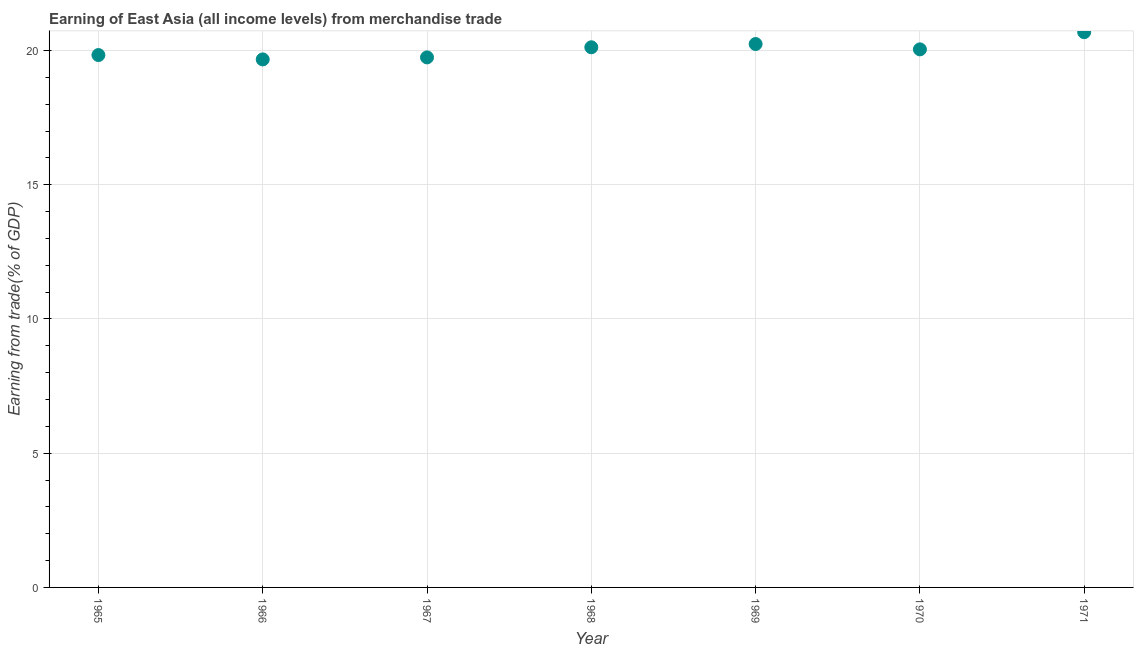What is the earning from merchandise trade in 1968?
Keep it short and to the point. 20.12. Across all years, what is the maximum earning from merchandise trade?
Make the answer very short. 20.68. Across all years, what is the minimum earning from merchandise trade?
Make the answer very short. 19.67. In which year was the earning from merchandise trade maximum?
Offer a very short reply. 1971. In which year was the earning from merchandise trade minimum?
Offer a terse response. 1966. What is the sum of the earning from merchandise trade?
Make the answer very short. 140.34. What is the difference between the earning from merchandise trade in 1969 and 1970?
Offer a terse response. 0.2. What is the average earning from merchandise trade per year?
Your answer should be very brief. 20.05. What is the median earning from merchandise trade?
Your answer should be compact. 20.04. In how many years, is the earning from merchandise trade greater than 1 %?
Offer a very short reply. 7. Do a majority of the years between 1971 and 1966 (inclusive) have earning from merchandise trade greater than 4 %?
Make the answer very short. Yes. What is the ratio of the earning from merchandise trade in 1966 to that in 1971?
Keep it short and to the point. 0.95. Is the earning from merchandise trade in 1965 less than that in 1971?
Your response must be concise. Yes. Is the difference between the earning from merchandise trade in 1967 and 1968 greater than the difference between any two years?
Provide a short and direct response. No. What is the difference between the highest and the second highest earning from merchandise trade?
Your answer should be very brief. 0.44. What is the difference between the highest and the lowest earning from merchandise trade?
Your answer should be very brief. 1.01. What is the difference between two consecutive major ticks on the Y-axis?
Give a very brief answer. 5. What is the title of the graph?
Give a very brief answer. Earning of East Asia (all income levels) from merchandise trade. What is the label or title of the X-axis?
Make the answer very short. Year. What is the label or title of the Y-axis?
Your answer should be compact. Earning from trade(% of GDP). What is the Earning from trade(% of GDP) in 1965?
Your response must be concise. 19.83. What is the Earning from trade(% of GDP) in 1966?
Keep it short and to the point. 19.67. What is the Earning from trade(% of GDP) in 1967?
Ensure brevity in your answer.  19.75. What is the Earning from trade(% of GDP) in 1968?
Ensure brevity in your answer.  20.12. What is the Earning from trade(% of GDP) in 1969?
Offer a very short reply. 20.24. What is the Earning from trade(% of GDP) in 1970?
Your answer should be very brief. 20.04. What is the Earning from trade(% of GDP) in 1971?
Make the answer very short. 20.68. What is the difference between the Earning from trade(% of GDP) in 1965 and 1966?
Ensure brevity in your answer.  0.16. What is the difference between the Earning from trade(% of GDP) in 1965 and 1967?
Your response must be concise. 0.09. What is the difference between the Earning from trade(% of GDP) in 1965 and 1968?
Make the answer very short. -0.29. What is the difference between the Earning from trade(% of GDP) in 1965 and 1969?
Give a very brief answer. -0.41. What is the difference between the Earning from trade(% of GDP) in 1965 and 1970?
Make the answer very short. -0.21. What is the difference between the Earning from trade(% of GDP) in 1965 and 1971?
Give a very brief answer. -0.85. What is the difference between the Earning from trade(% of GDP) in 1966 and 1967?
Offer a very short reply. -0.08. What is the difference between the Earning from trade(% of GDP) in 1966 and 1968?
Keep it short and to the point. -0.45. What is the difference between the Earning from trade(% of GDP) in 1966 and 1969?
Make the answer very short. -0.57. What is the difference between the Earning from trade(% of GDP) in 1966 and 1970?
Your answer should be compact. -0.37. What is the difference between the Earning from trade(% of GDP) in 1966 and 1971?
Give a very brief answer. -1.01. What is the difference between the Earning from trade(% of GDP) in 1967 and 1968?
Your response must be concise. -0.38. What is the difference between the Earning from trade(% of GDP) in 1967 and 1969?
Your answer should be very brief. -0.5. What is the difference between the Earning from trade(% of GDP) in 1967 and 1970?
Make the answer very short. -0.3. What is the difference between the Earning from trade(% of GDP) in 1967 and 1971?
Make the answer very short. -0.94. What is the difference between the Earning from trade(% of GDP) in 1968 and 1969?
Your response must be concise. -0.12. What is the difference between the Earning from trade(% of GDP) in 1968 and 1970?
Your answer should be very brief. 0.08. What is the difference between the Earning from trade(% of GDP) in 1968 and 1971?
Provide a succinct answer. -0.56. What is the difference between the Earning from trade(% of GDP) in 1969 and 1970?
Your answer should be compact. 0.2. What is the difference between the Earning from trade(% of GDP) in 1969 and 1971?
Make the answer very short. -0.44. What is the difference between the Earning from trade(% of GDP) in 1970 and 1971?
Keep it short and to the point. -0.64. What is the ratio of the Earning from trade(% of GDP) in 1965 to that in 1966?
Ensure brevity in your answer.  1.01. What is the ratio of the Earning from trade(% of GDP) in 1965 to that in 1967?
Offer a terse response. 1. What is the ratio of the Earning from trade(% of GDP) in 1966 to that in 1967?
Give a very brief answer. 1. What is the ratio of the Earning from trade(% of GDP) in 1966 to that in 1968?
Keep it short and to the point. 0.98. What is the ratio of the Earning from trade(% of GDP) in 1966 to that in 1970?
Provide a short and direct response. 0.98. What is the ratio of the Earning from trade(% of GDP) in 1966 to that in 1971?
Provide a short and direct response. 0.95. What is the ratio of the Earning from trade(% of GDP) in 1967 to that in 1971?
Your answer should be very brief. 0.95. What is the ratio of the Earning from trade(% of GDP) in 1969 to that in 1971?
Provide a succinct answer. 0.98. 